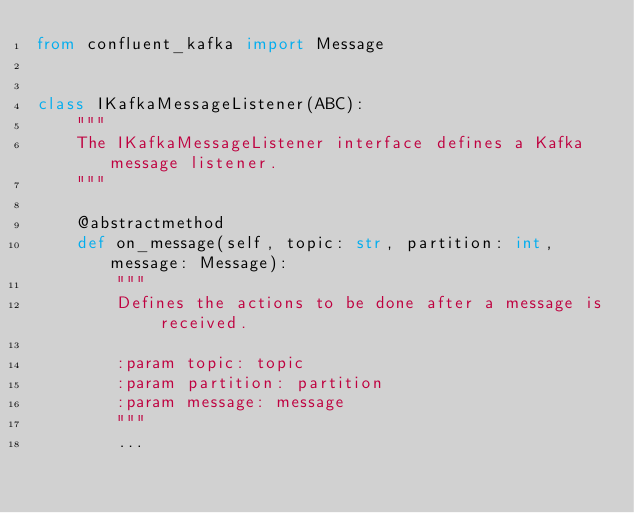<code> <loc_0><loc_0><loc_500><loc_500><_Python_>from confluent_kafka import Message


class IKafkaMessageListener(ABC):
    """
    The IKafkaMessageListener interface defines a Kafka message listener.
    """

    @abstractmethod
    def on_message(self, topic: str, partition: int, message: Message):
        """
        Defines the actions to be done after a message is received.

        :param topic: topic
        :param partition: partition
        :param message: message
        """
        ...
</code> 